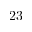<formula> <loc_0><loc_0><loc_500><loc_500>2 3</formula> 